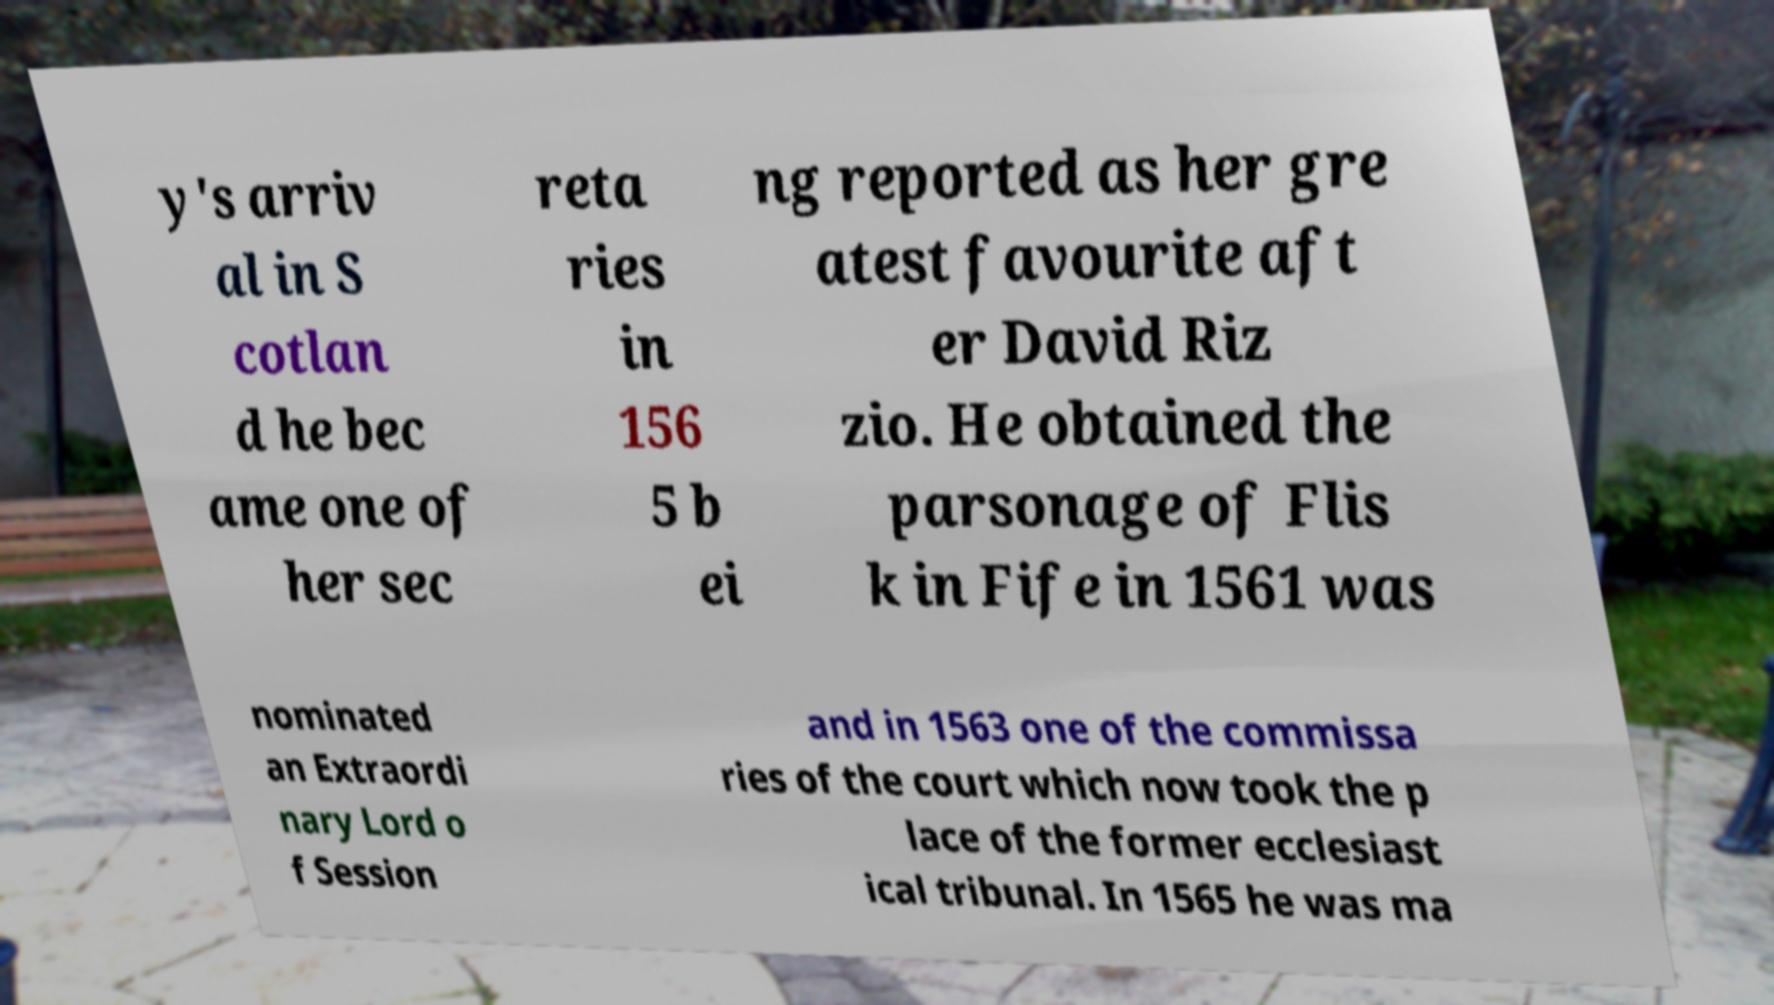Could you assist in decoding the text presented in this image and type it out clearly? y's arriv al in S cotlan d he bec ame one of her sec reta ries in 156 5 b ei ng reported as her gre atest favourite aft er David Riz zio. He obtained the parsonage of Flis k in Fife in 1561 was nominated an Extraordi nary Lord o f Session and in 1563 one of the commissa ries of the court which now took the p lace of the former ecclesiast ical tribunal. In 1565 he was ma 